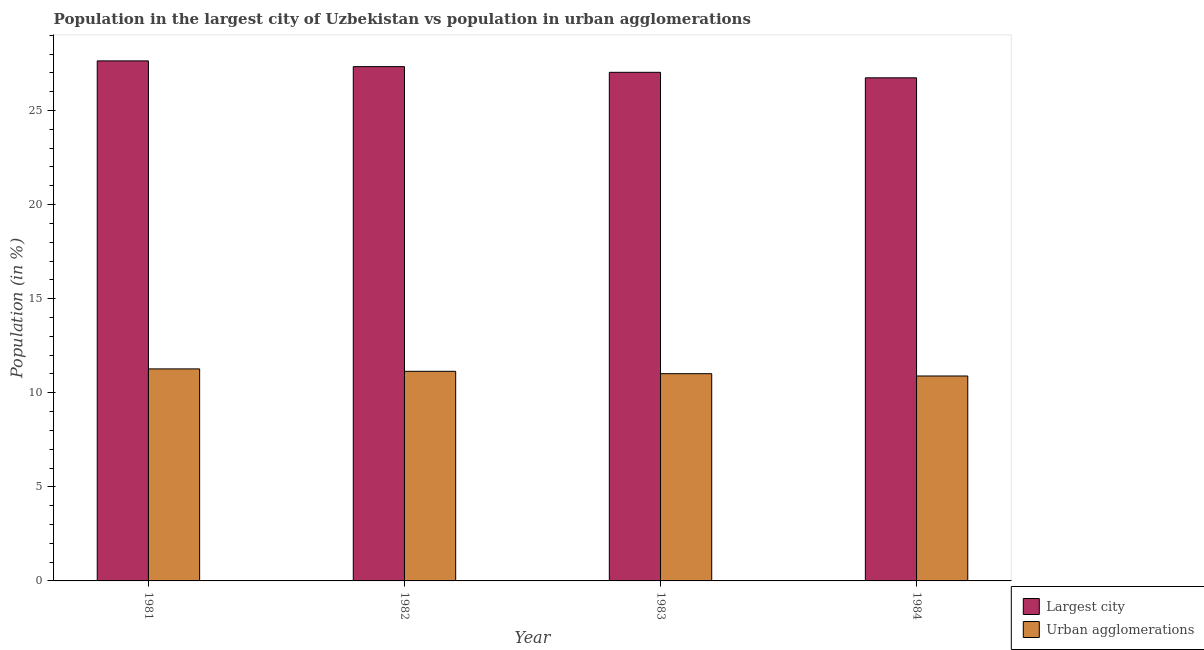How many different coloured bars are there?
Your answer should be compact. 2. How many groups of bars are there?
Make the answer very short. 4. How many bars are there on the 4th tick from the left?
Offer a terse response. 2. How many bars are there on the 3rd tick from the right?
Give a very brief answer. 2. What is the population in the largest city in 1983?
Keep it short and to the point. 27.03. Across all years, what is the maximum population in the largest city?
Offer a terse response. 27.64. Across all years, what is the minimum population in the largest city?
Your answer should be very brief. 26.74. In which year was the population in the largest city maximum?
Provide a short and direct response. 1981. What is the total population in urban agglomerations in the graph?
Keep it short and to the point. 44.31. What is the difference between the population in the largest city in 1982 and that in 1983?
Give a very brief answer. 0.3. What is the difference between the population in urban agglomerations in 1984 and the population in the largest city in 1982?
Offer a terse response. -0.25. What is the average population in the largest city per year?
Offer a very short reply. 27.18. In the year 1981, what is the difference between the population in urban agglomerations and population in the largest city?
Your response must be concise. 0. What is the ratio of the population in urban agglomerations in 1981 to that in 1982?
Offer a very short reply. 1.01. Is the difference between the population in the largest city in 1982 and 1984 greater than the difference between the population in urban agglomerations in 1982 and 1984?
Give a very brief answer. No. What is the difference between the highest and the second highest population in urban agglomerations?
Offer a very short reply. 0.13. What is the difference between the highest and the lowest population in urban agglomerations?
Your response must be concise. 0.38. Is the sum of the population in urban agglomerations in 1981 and 1982 greater than the maximum population in the largest city across all years?
Ensure brevity in your answer.  Yes. What does the 2nd bar from the left in 1981 represents?
Keep it short and to the point. Urban agglomerations. What does the 2nd bar from the right in 1982 represents?
Your answer should be compact. Largest city. How many bars are there?
Provide a succinct answer. 8. Are all the bars in the graph horizontal?
Offer a very short reply. No. Does the graph contain grids?
Keep it short and to the point. No. Where does the legend appear in the graph?
Keep it short and to the point. Bottom right. How are the legend labels stacked?
Your answer should be compact. Vertical. What is the title of the graph?
Your response must be concise. Population in the largest city of Uzbekistan vs population in urban agglomerations. What is the Population (in %) in Largest city in 1981?
Provide a short and direct response. 27.64. What is the Population (in %) in Urban agglomerations in 1981?
Give a very brief answer. 11.27. What is the Population (in %) of Largest city in 1982?
Offer a terse response. 27.33. What is the Population (in %) in Urban agglomerations in 1982?
Make the answer very short. 11.14. What is the Population (in %) in Largest city in 1983?
Your response must be concise. 27.03. What is the Population (in %) of Urban agglomerations in 1983?
Offer a terse response. 11.01. What is the Population (in %) of Largest city in 1984?
Your answer should be compact. 26.74. What is the Population (in %) in Urban agglomerations in 1984?
Provide a short and direct response. 10.89. Across all years, what is the maximum Population (in %) in Largest city?
Your response must be concise. 27.64. Across all years, what is the maximum Population (in %) of Urban agglomerations?
Provide a short and direct response. 11.27. Across all years, what is the minimum Population (in %) in Largest city?
Keep it short and to the point. 26.74. Across all years, what is the minimum Population (in %) in Urban agglomerations?
Your response must be concise. 10.89. What is the total Population (in %) in Largest city in the graph?
Your response must be concise. 108.73. What is the total Population (in %) in Urban agglomerations in the graph?
Make the answer very short. 44.31. What is the difference between the Population (in %) in Largest city in 1981 and that in 1982?
Ensure brevity in your answer.  0.31. What is the difference between the Population (in %) of Urban agglomerations in 1981 and that in 1982?
Offer a terse response. 0.13. What is the difference between the Population (in %) in Largest city in 1981 and that in 1983?
Give a very brief answer. 0.61. What is the difference between the Population (in %) in Urban agglomerations in 1981 and that in 1983?
Ensure brevity in your answer.  0.25. What is the difference between the Population (in %) in Largest city in 1981 and that in 1984?
Provide a succinct answer. 0.9. What is the difference between the Population (in %) of Urban agglomerations in 1981 and that in 1984?
Ensure brevity in your answer.  0.38. What is the difference between the Population (in %) of Largest city in 1982 and that in 1983?
Your answer should be very brief. 0.3. What is the difference between the Population (in %) in Urban agglomerations in 1982 and that in 1983?
Make the answer very short. 0.13. What is the difference between the Population (in %) of Largest city in 1982 and that in 1984?
Your response must be concise. 0.59. What is the difference between the Population (in %) in Urban agglomerations in 1982 and that in 1984?
Provide a succinct answer. 0.25. What is the difference between the Population (in %) of Largest city in 1983 and that in 1984?
Ensure brevity in your answer.  0.29. What is the difference between the Population (in %) of Urban agglomerations in 1983 and that in 1984?
Your response must be concise. 0.12. What is the difference between the Population (in %) in Largest city in 1981 and the Population (in %) in Urban agglomerations in 1982?
Offer a very short reply. 16.5. What is the difference between the Population (in %) of Largest city in 1981 and the Population (in %) of Urban agglomerations in 1983?
Ensure brevity in your answer.  16.62. What is the difference between the Population (in %) in Largest city in 1981 and the Population (in %) in Urban agglomerations in 1984?
Provide a short and direct response. 16.75. What is the difference between the Population (in %) in Largest city in 1982 and the Population (in %) in Urban agglomerations in 1983?
Your answer should be very brief. 16.32. What is the difference between the Population (in %) of Largest city in 1982 and the Population (in %) of Urban agglomerations in 1984?
Provide a short and direct response. 16.44. What is the difference between the Population (in %) of Largest city in 1983 and the Population (in %) of Urban agglomerations in 1984?
Your answer should be compact. 16.14. What is the average Population (in %) of Largest city per year?
Provide a succinct answer. 27.18. What is the average Population (in %) in Urban agglomerations per year?
Your response must be concise. 11.08. In the year 1981, what is the difference between the Population (in %) in Largest city and Population (in %) in Urban agglomerations?
Your response must be concise. 16.37. In the year 1982, what is the difference between the Population (in %) of Largest city and Population (in %) of Urban agglomerations?
Provide a short and direct response. 16.19. In the year 1983, what is the difference between the Population (in %) of Largest city and Population (in %) of Urban agglomerations?
Provide a succinct answer. 16.02. In the year 1984, what is the difference between the Population (in %) in Largest city and Population (in %) in Urban agglomerations?
Make the answer very short. 15.85. What is the ratio of the Population (in %) in Largest city in 1981 to that in 1982?
Offer a very short reply. 1.01. What is the ratio of the Population (in %) in Urban agglomerations in 1981 to that in 1982?
Your answer should be very brief. 1.01. What is the ratio of the Population (in %) in Largest city in 1981 to that in 1983?
Your answer should be very brief. 1.02. What is the ratio of the Population (in %) of Urban agglomerations in 1981 to that in 1983?
Offer a very short reply. 1.02. What is the ratio of the Population (in %) in Largest city in 1981 to that in 1984?
Provide a short and direct response. 1.03. What is the ratio of the Population (in %) of Urban agglomerations in 1981 to that in 1984?
Offer a terse response. 1.03. What is the ratio of the Population (in %) in Largest city in 1982 to that in 1983?
Your answer should be compact. 1.01. What is the ratio of the Population (in %) of Urban agglomerations in 1982 to that in 1983?
Your answer should be very brief. 1.01. What is the ratio of the Population (in %) in Largest city in 1982 to that in 1984?
Your response must be concise. 1.02. What is the ratio of the Population (in %) of Urban agglomerations in 1982 to that in 1984?
Your answer should be compact. 1.02. What is the ratio of the Population (in %) of Largest city in 1983 to that in 1984?
Provide a succinct answer. 1.01. What is the ratio of the Population (in %) of Urban agglomerations in 1983 to that in 1984?
Provide a short and direct response. 1.01. What is the difference between the highest and the second highest Population (in %) of Largest city?
Provide a succinct answer. 0.31. What is the difference between the highest and the second highest Population (in %) of Urban agglomerations?
Keep it short and to the point. 0.13. What is the difference between the highest and the lowest Population (in %) in Largest city?
Your answer should be compact. 0.9. What is the difference between the highest and the lowest Population (in %) of Urban agglomerations?
Keep it short and to the point. 0.38. 